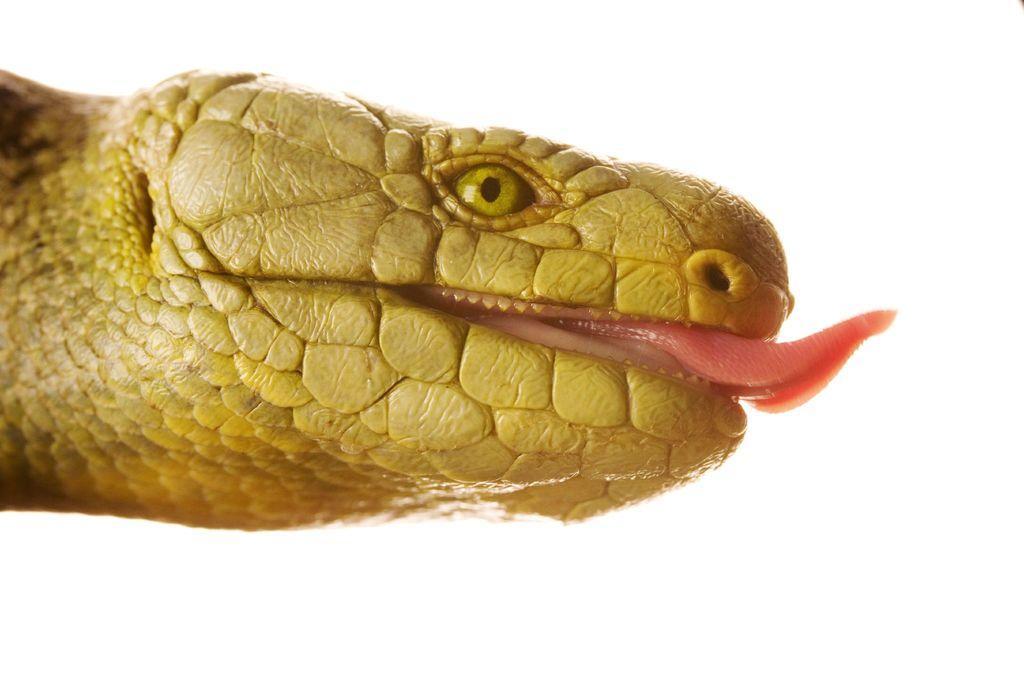Describe this image in one or two sentences. In this picture, we see a reptile which looks like a snake. It is in yellow color. In the background, it is white in color. 